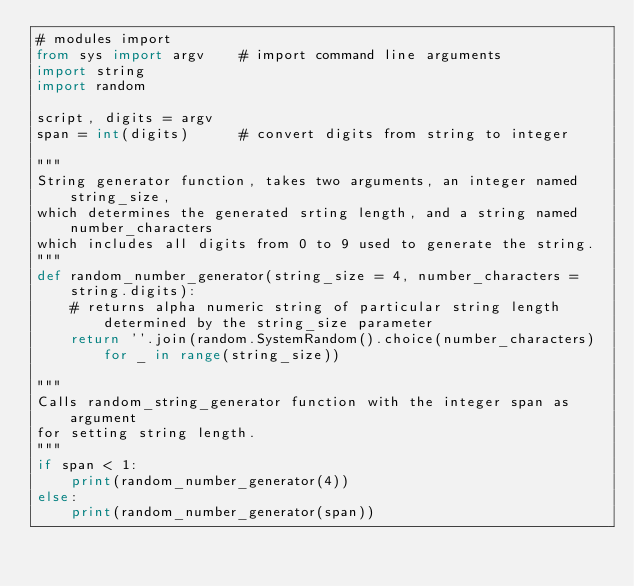Convert code to text. <code><loc_0><loc_0><loc_500><loc_500><_Python_># modules import
from sys import argv    # import command line arguments
import string
import random

script, digits = argv
span = int(digits)      # convert digits from string to integer

"""
String generator function, takes two arguments, an integer named string_size,
which determines the generated srting length, and a string named number_characters
which includes all digits from 0 to 9 used to generate the string.
"""
def random_number_generator(string_size = 4, number_characters = string.digits):
	# returns alpha numeric string of particular string length determined by the string_size parameter
	return ''.join(random.SystemRandom().choice(number_characters) for _ in range(string_size))

"""
Calls random_string_generator function with the integer span as argument
for setting string length.
"""
if span < 1:
    print(random_number_generator(4))
else:
    print(random_number_generator(span))
</code> 